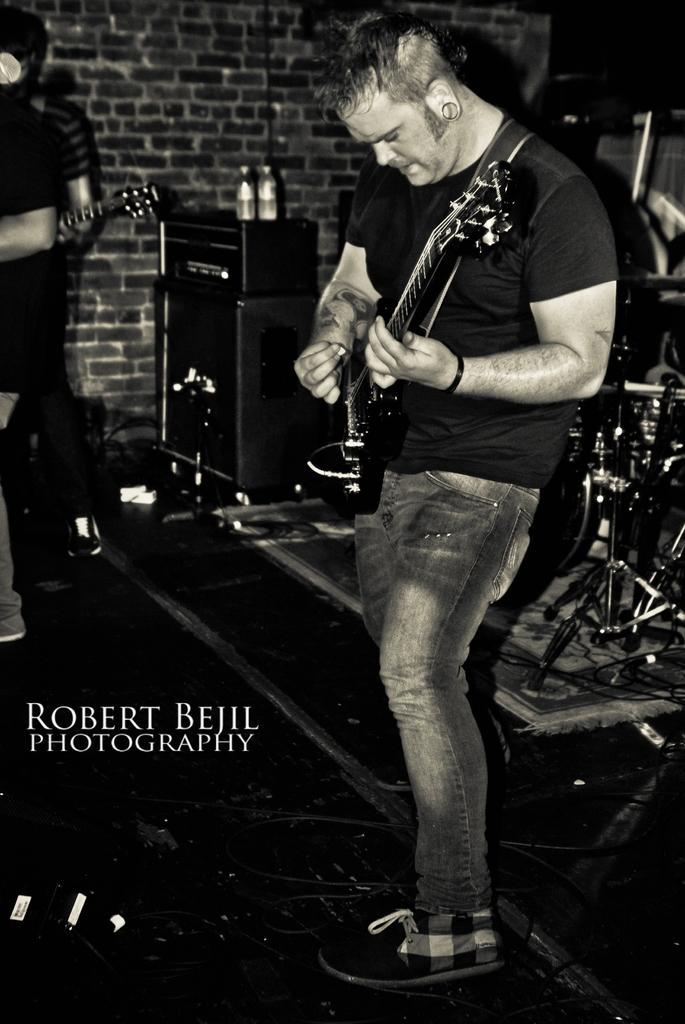What is the man in the image doing? The man is holding a guitar and playing. What can be seen in the background of the image? There are drums, tables, and a brick wall in the background. What is on the tables in the image? There are bottles on the tables. Are there any other musicians in the image? Yes, there are other persons standing and holding guitars. What type of drawer is being used to power the guitar in the image? There is no drawer present in the image, and guitars do not require power to function. 